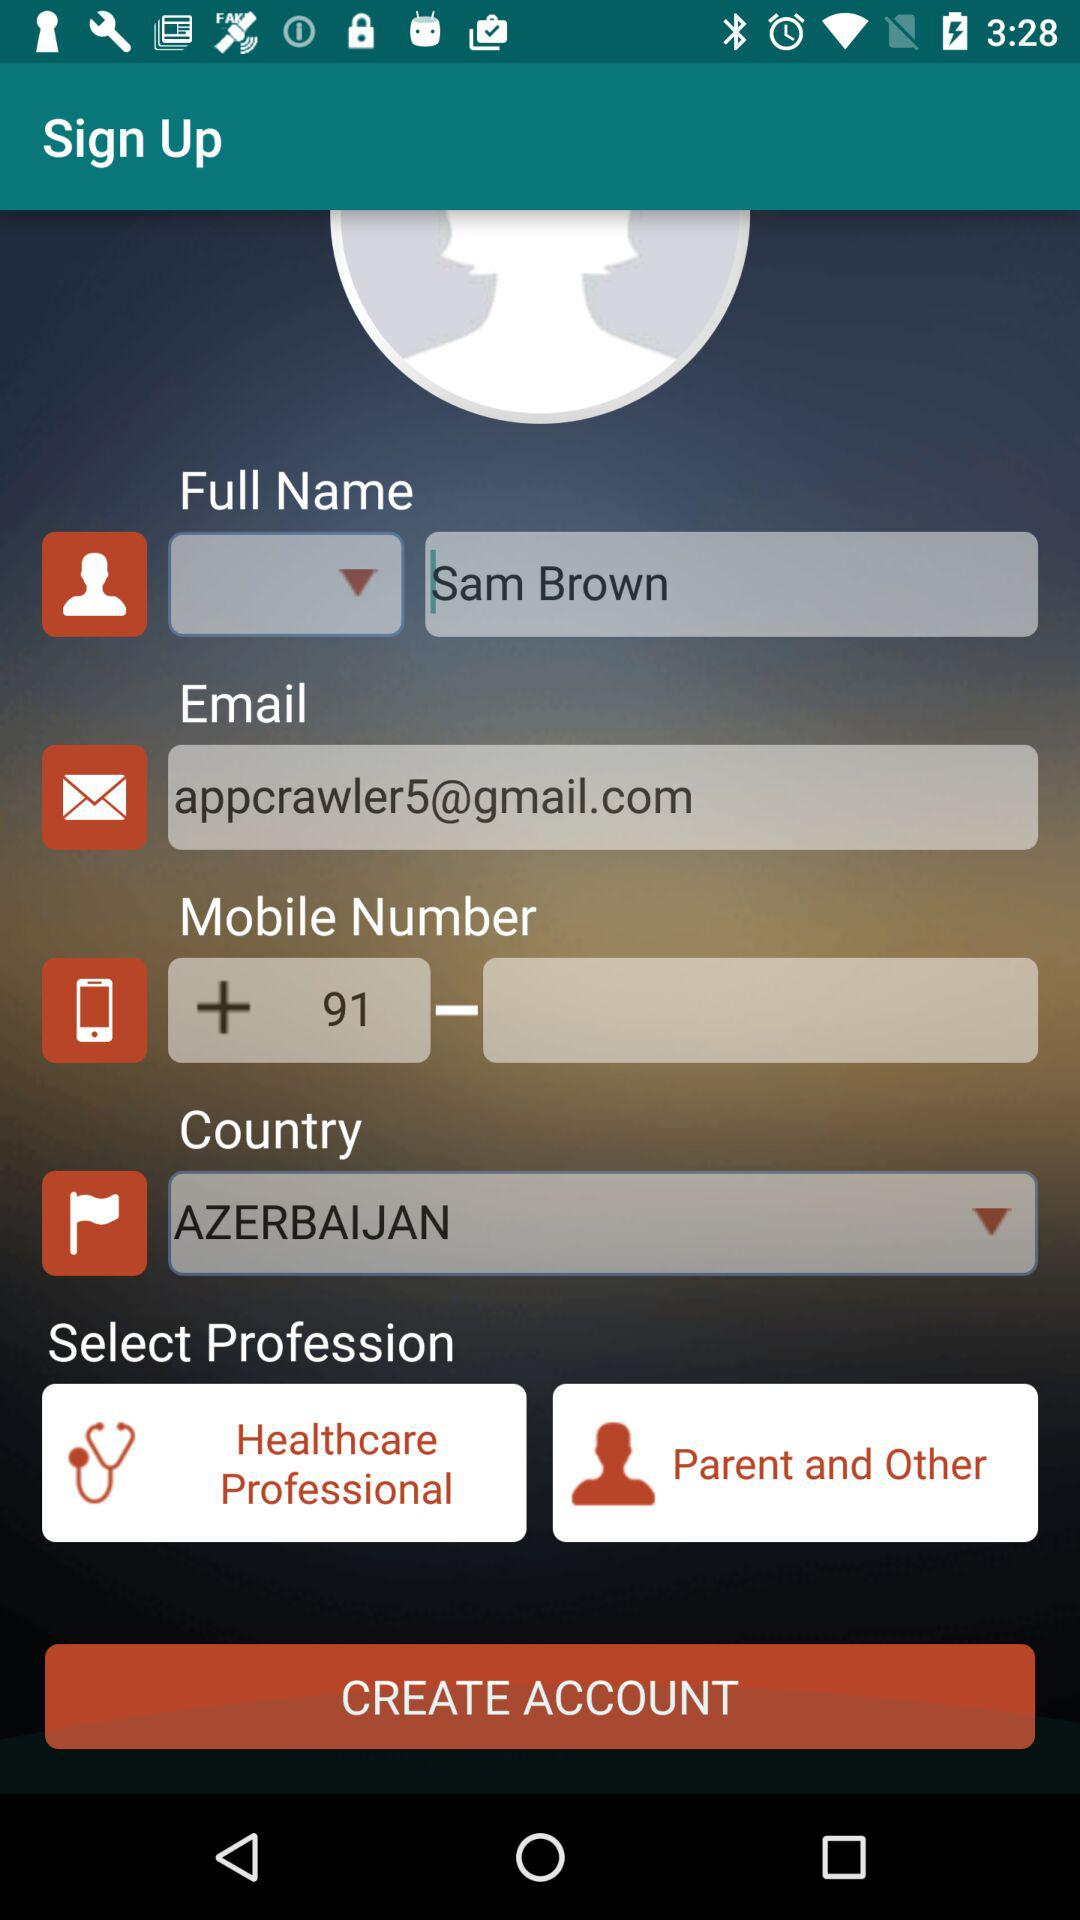What is the country name? The country name is Azerbaijan. 